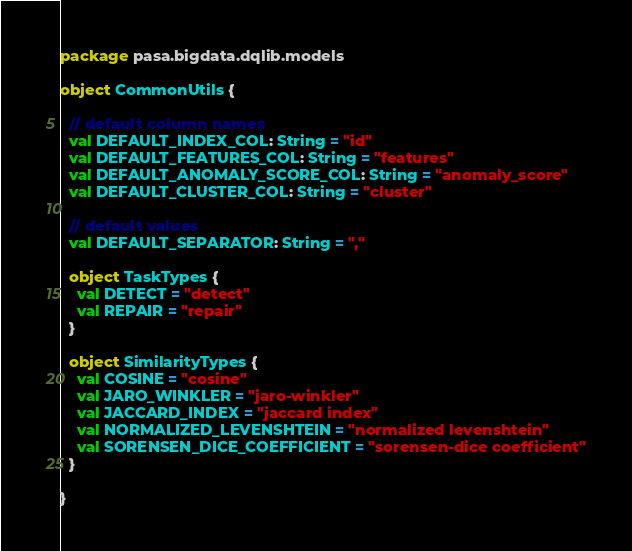Convert code to text. <code><loc_0><loc_0><loc_500><loc_500><_Scala_>package pasa.bigdata.dqlib.models

object CommonUtils {

  // default column names
  val DEFAULT_INDEX_COL: String = "id"
  val DEFAULT_FEATURES_COL: String = "features"
  val DEFAULT_ANOMALY_SCORE_COL: String = "anomaly_score"
  val DEFAULT_CLUSTER_COL: String = "cluster"

  // default values
  val DEFAULT_SEPARATOR: String = ","

  object TaskTypes {
    val DETECT = "detect"
    val REPAIR = "repair"
  }

  object SimilarityTypes {
    val COSINE = "cosine"
    val JARO_WINKLER = "jaro-winkler"
    val JACCARD_INDEX = "jaccard index"
    val NORMALIZED_LEVENSHTEIN = "normalized levenshtein"
    val SORENSEN_DICE_COEFFICIENT = "sorensen-dice coefficient"
  }

}
</code> 